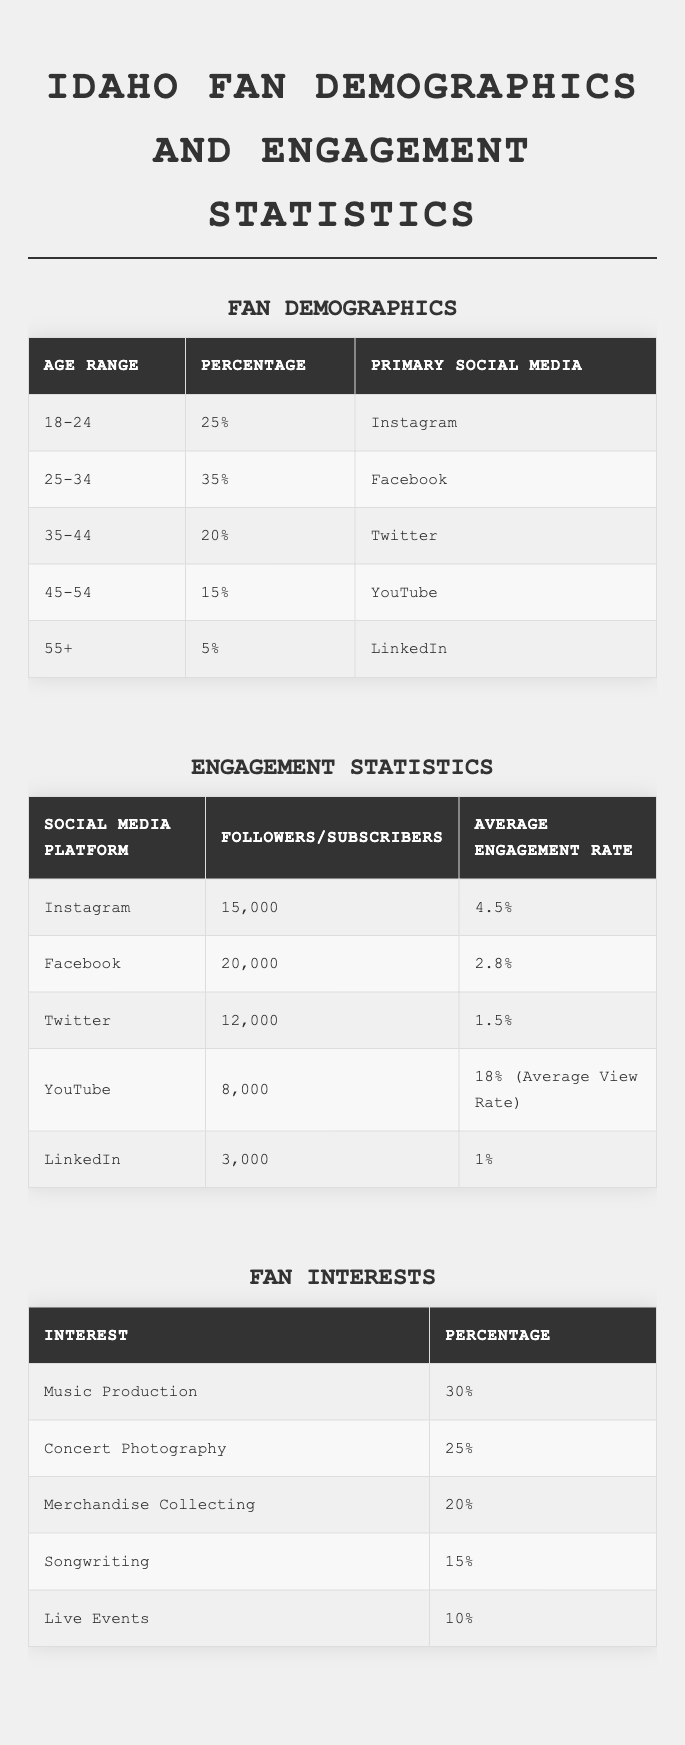What age range has the highest percentage of fans? By looking at the Fan Demographics table, the highest percentage is 35% for the age range 25-34.
Answer: 25-34 What is the primary social media platform for fans aged 18-24? The table shows that the primary social media for fans aged 18-24 is Instagram.
Answer: Instagram How many total followers do Idaho have across their social media platforms? Adding up the followers: Instagram (15,000) + Facebook (20,000) + Twitter (12,000) + LinkedIn (3,000) gives a total of 50,000. YouTube is stated in subscribers, which does not contribute to the total follower count.
Answer: 50,000 Which age range has the lowest engagement with social media? The age range with the lowest percentage of fans is 55+ with just 5%.
Answer: 55+ What is the average engagement rate across Instagram, Facebook, and Twitter? Adding the engagement rates: 4.5% (Instagram) + 2.8% (Facebook) + 1.5% (Twitter) = 8.8%. To find the average, divide by 3: 8.8% / 3 = 2.93%.
Answer: 2.93% Is the engagement rate for YouTube higher than that of Instagram? The average view rate for YouTube is 18%, while Instagram’s engagement rate is 4.5%. Since 18% is greater than 4.5%, the statement is true.
Answer: Yes What percentage of fans are interested in merchandise collecting? Referring to the Fan Interests table, 20% of fans are interested in merchandise collecting.
Answer: 20% Which platform has the highest average engagement rate? The Engagement Statistics table shows that YouTube has the highest average view rate of 18%, higher than all engagement rates for other platforms.
Answer: YouTube If 30% of the fans are interested in music production, what percentage are not? To find the percentage of fans not interested in music production, subtract 30% from 100%. Therefore, 100% - 30% = 70%.
Answer: 70% How many more followers does Facebook have compared to Twitter? The difference in followers is calculated as follows: Facebook (20,000) - Twitter (12,000) = 8,000, so Facebook has 8,000 more followers than Twitter.
Answer: 8,000 What is the primary social media platform for fans aged 45-54? According to the Fan Demographics table, the primary social media for fans aged 45-54 is YouTube.
Answer: YouTube 